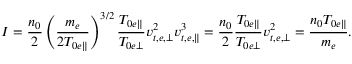Convert formula to latex. <formula><loc_0><loc_0><loc_500><loc_500>I = \frac { n _ { 0 } } { 2 } \left ( \frac { m _ { e } } { 2 T _ { 0 e \| } } \right ) ^ { 3 / 2 } \frac { T _ { 0 e \| } } { T _ { 0 e \perp } } v _ { t , e , \perp } ^ { 2 } v _ { t , e , \| } ^ { 3 } = \frac { n _ { 0 } } { 2 } \frac { T _ { 0 e \| } } { T _ { 0 e \perp } } v _ { t , e , \perp } ^ { 2 } = \frac { n _ { 0 } T _ { 0 e \| } } { m _ { e } } .</formula> 